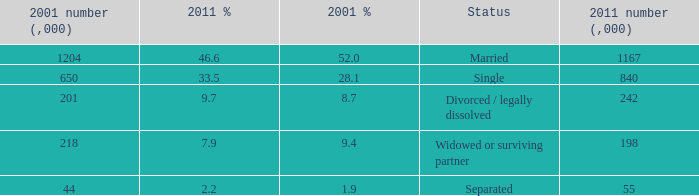Parse the table in full. {'header': ['2001 number (,000)', '2011 %', '2001 %', 'Status', '2011 number (,000)'], 'rows': [['1204', '46.6', '52.0', 'Married', '1167'], ['650', '33.5', '28.1', 'Single', '840'], ['201', '9.7', '8.7', 'Divorced / legally dissolved', '242'], ['218', '7.9', '9.4', 'Widowed or surviving partner', '198'], ['44', '2.2', '1.9', 'Separated', '55']]} How many 2011 % is 7.9? 1.0. 